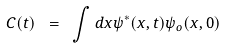Convert formula to latex. <formula><loc_0><loc_0><loc_500><loc_500>C ( t ) \ = \ \int d x \psi ^ { * } ( x , t ) \psi _ { o } ( x , 0 )</formula> 